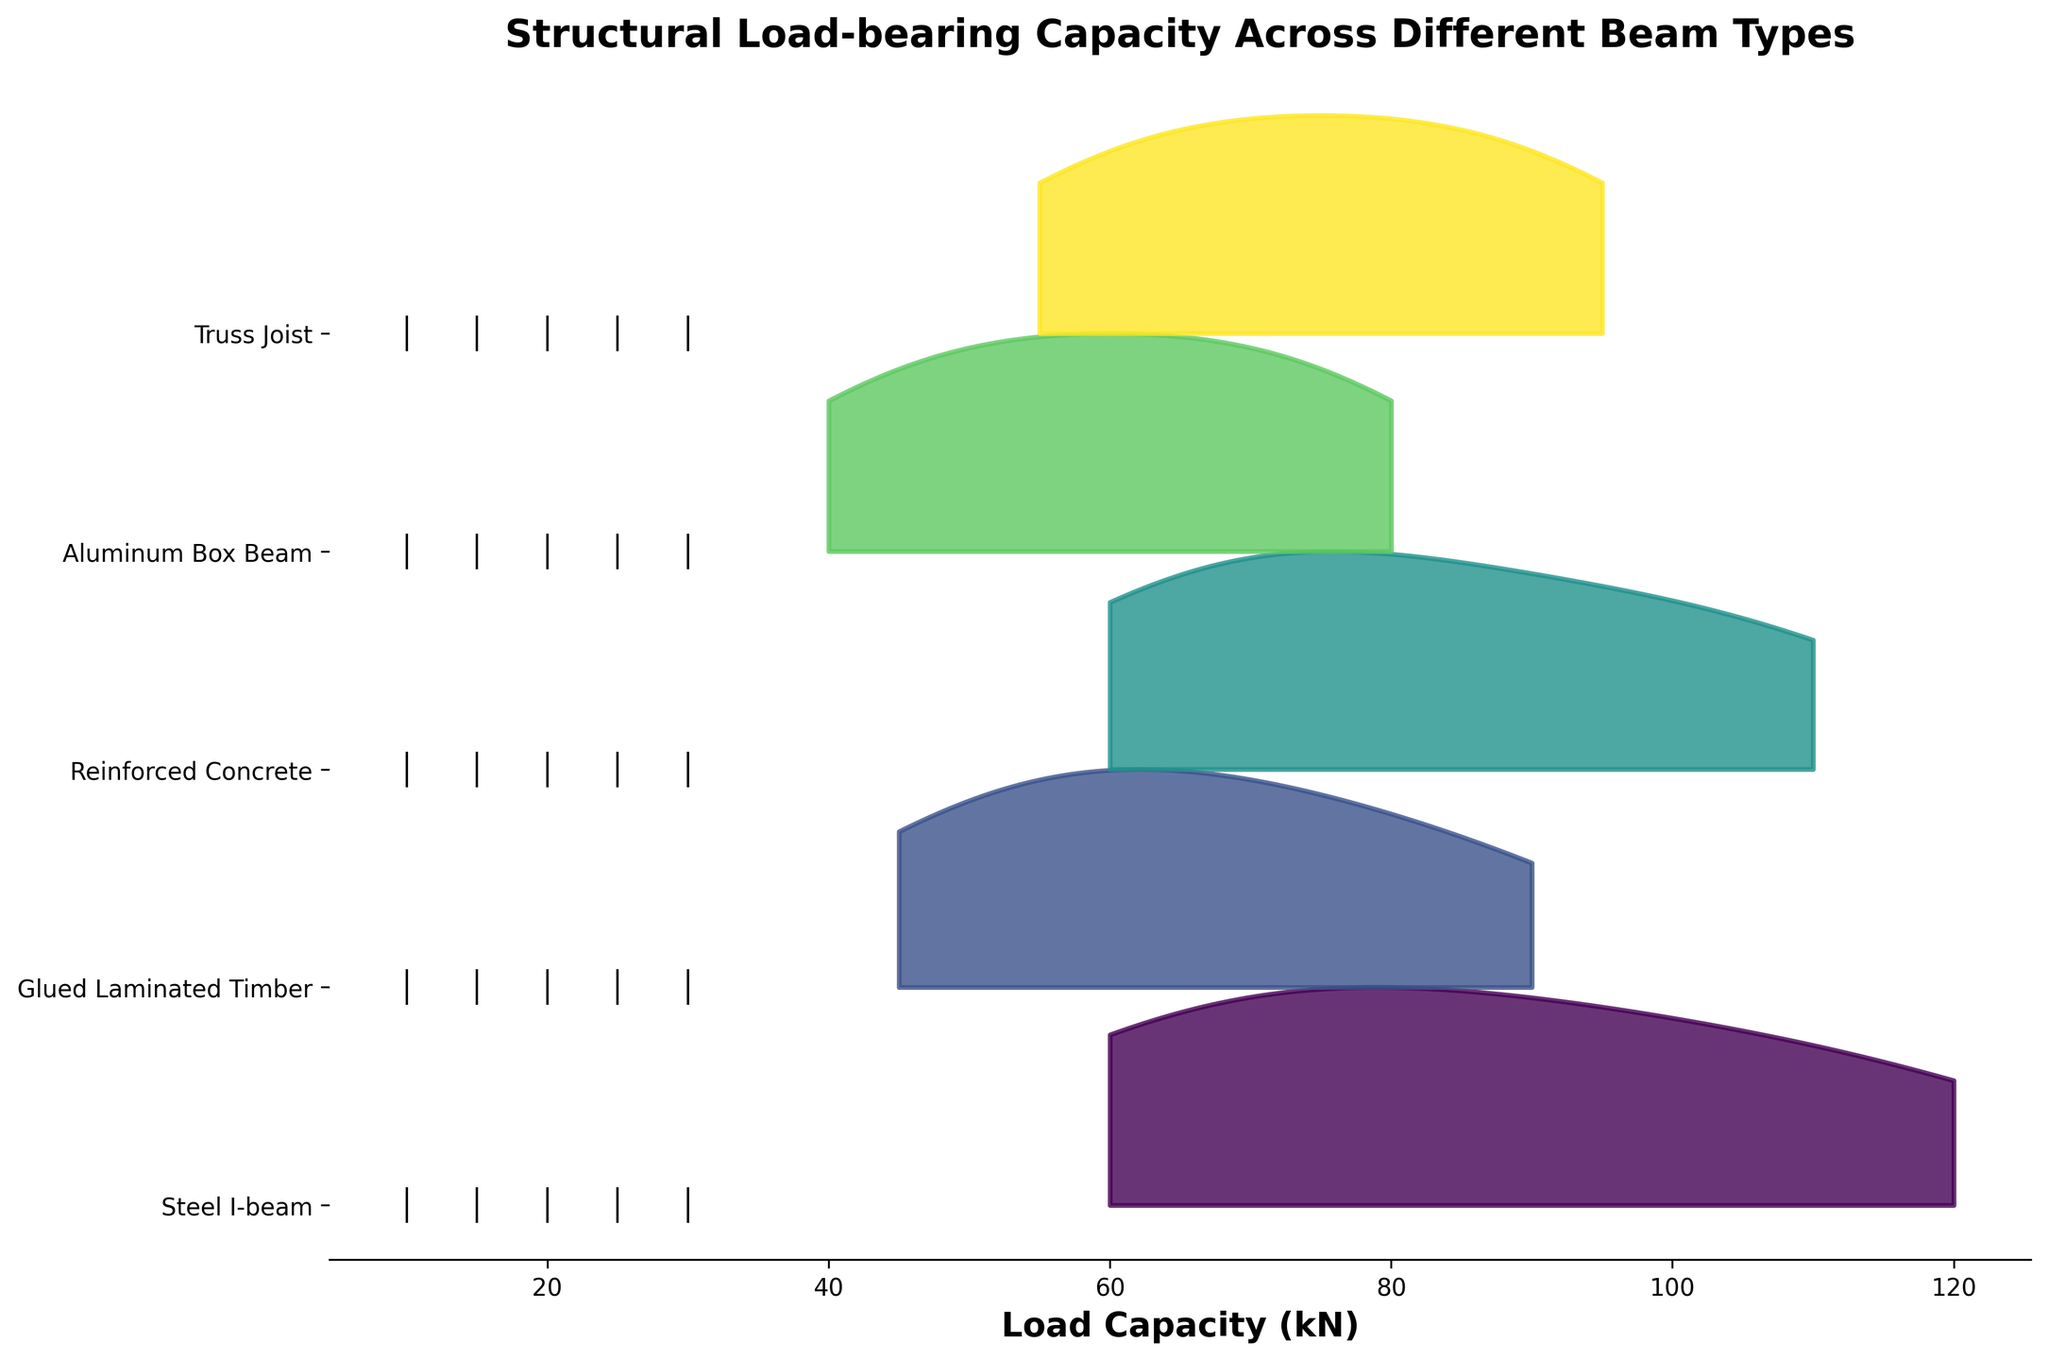What beam type has the highest average load-bearing capacity? To determine the beam type with the highest average load-bearing capacity, look at the range and density of each beam type's load capacity values in the ridgeline plot. The Steel I-beam shows the highest values overall across different spans.
Answer: Steel I-beam What's the span length range for the Glued Laminated Timber beam? Identify the start and end points of the "Glued Laminated Timber" ridgeline plot. The span lengths indicated by the markers range from 10 to 30 meters.
Answer: 10 to 30 meters Which beam type has the narrowest distribution of load capacities? By comparing the width of the peaks in the ridgeline plot for each beam type, the Aluminum Box Beam appears to have the narrowest distribution, indicated by a sharp, narrow curve.
Answer: Aluminum Box Beam What is the maximum load capacity observed for the Reinforced Concrete beam? The maximum load capacity observed for the Reinforced Concrete beam in the ridgeline plot is found at the upper end of its distribution, which is around 110 kN.
Answer: 110 kN Compare the load capacities between the Steel I-beam and Truss Joist beams at a span length of 20m. Which one is higher? For a span length of 20 meters, locate the specific markers for Steel I-beam and Truss Joist on the ridgeline plot and compare their positions on the load capacity axis. The Steel I-beam has a higher load capacity at 85 kN, compared to the Truss Joist's 75 kN.
Answer: Steel I-beam How does the load capacity generally change with increasing span length? Observe the general trend of load capacities across all beam types as span length increases. There is a consistent pattern of decreasing load capacity as the span length increases from 10 to 30 meters.
Answer: Decreases Which beam type shows the steepest decline in load capacity with increasing span length? Look at the steepness of the ridgeline plot's downward slope for each beam type. The Glued Laminated Timber shows the steepest decline in load capacity as the span length increases.
Answer: Glued Laminated Timber What is the approximate load capacity for Aluminum Box Beam at a 15-meter span? Locate the marker for Aluminum Box Beam at 15 meters on the span length axis and observe its position on the load capacity axis, which is around 70 kN.
Answer: 70 kN Which two beam types have overlapping load capacity ranges at a span length of 25 meters? Find the markers at 25 meters for all beam types and check which ones have similar load capacity values. The Steel I-beam and Reinforced Concrete beams both have load capacities around 70 kN at this span length, showing an overlapping range.
Answer: Steel I-beam and Reinforced Concrete What does the overall shape of the ridgeline plot suggest about load capacities across different beam types? Interpret the overall visual distribution and density of the curves in the ridgeline plot. The plot suggests variability in load capacities among beam types, with some like Steel I-beam and Reinforced Concrete showing higher capacities, and others like Aluminum Box Beam showing lower capacities. Generally, load capacities decrease with increasing span length.
Answer: Variability in load capacities, decrease with increasing span length 